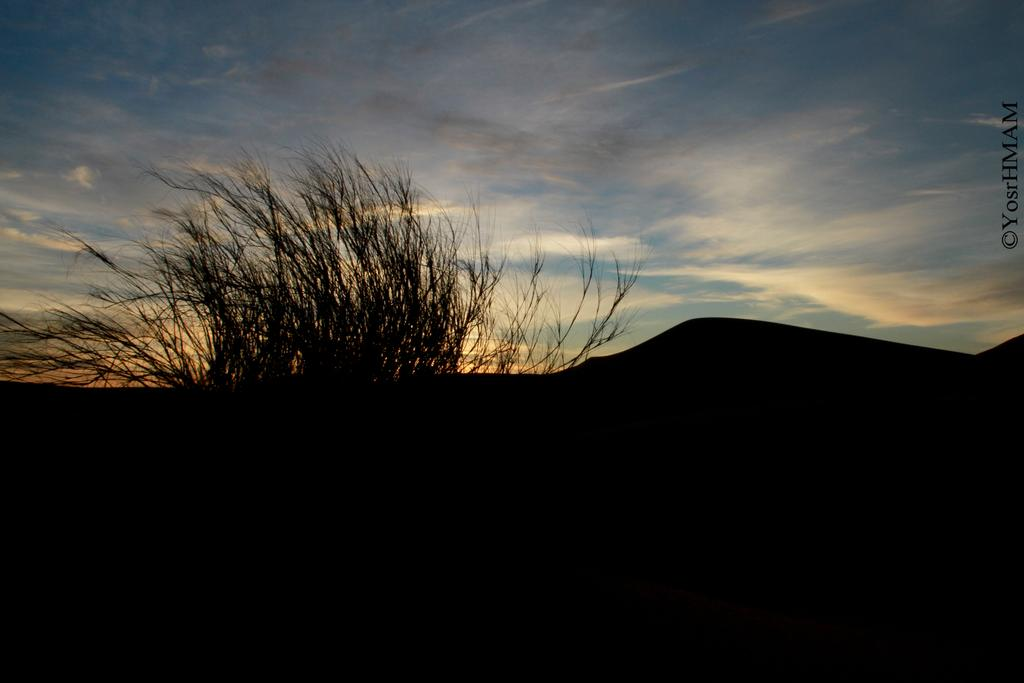What type of vegetation is in the middle of the image? There are bushes in the middle of the image. What can be seen in the background of the image? The sky is visible in the background of the image. How many threads are visible in the image? There is no reference to threads in the image, so it is not possible to determine how many threads might be visible. 